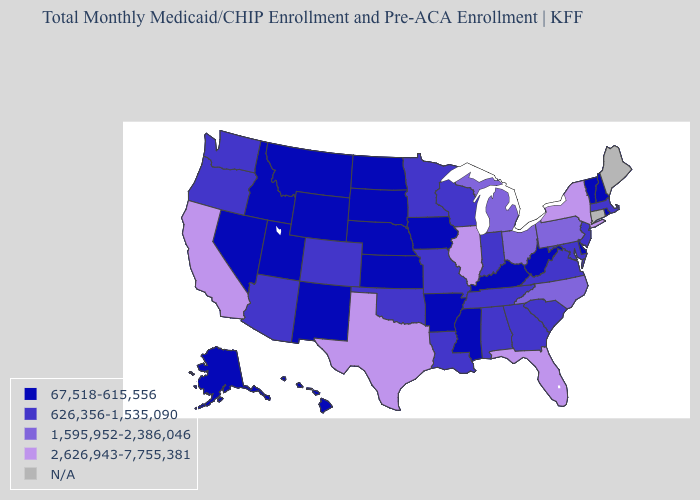What is the value of Alaska?
Answer briefly. 67,518-615,556. What is the highest value in states that border Kentucky?
Write a very short answer. 2,626,943-7,755,381. Does the map have missing data?
Answer briefly. Yes. Name the states that have a value in the range 67,518-615,556?
Answer briefly. Alaska, Arkansas, Delaware, Hawaii, Idaho, Iowa, Kansas, Kentucky, Mississippi, Montana, Nebraska, Nevada, New Hampshire, New Mexico, North Dakota, Rhode Island, South Dakota, Utah, Vermont, West Virginia, Wyoming. Name the states that have a value in the range 626,356-1,535,090?
Be succinct. Alabama, Arizona, Colorado, Georgia, Indiana, Louisiana, Maryland, Massachusetts, Minnesota, Missouri, New Jersey, Oklahoma, Oregon, South Carolina, Tennessee, Virginia, Washington, Wisconsin. Name the states that have a value in the range N/A?
Concise answer only. Connecticut, Maine. What is the highest value in the MidWest ?
Keep it brief. 2,626,943-7,755,381. How many symbols are there in the legend?
Write a very short answer. 5. Name the states that have a value in the range 2,626,943-7,755,381?
Give a very brief answer. California, Florida, Illinois, New York, Texas. Name the states that have a value in the range 1,595,952-2,386,046?
Concise answer only. Michigan, North Carolina, Ohio, Pennsylvania. Name the states that have a value in the range 626,356-1,535,090?
Concise answer only. Alabama, Arizona, Colorado, Georgia, Indiana, Louisiana, Maryland, Massachusetts, Minnesota, Missouri, New Jersey, Oklahoma, Oregon, South Carolina, Tennessee, Virginia, Washington, Wisconsin. What is the value of Louisiana?
Concise answer only. 626,356-1,535,090. What is the highest value in states that border California?
Give a very brief answer. 626,356-1,535,090. Name the states that have a value in the range 2,626,943-7,755,381?
Answer briefly. California, Florida, Illinois, New York, Texas. Name the states that have a value in the range N/A?
Short answer required. Connecticut, Maine. 